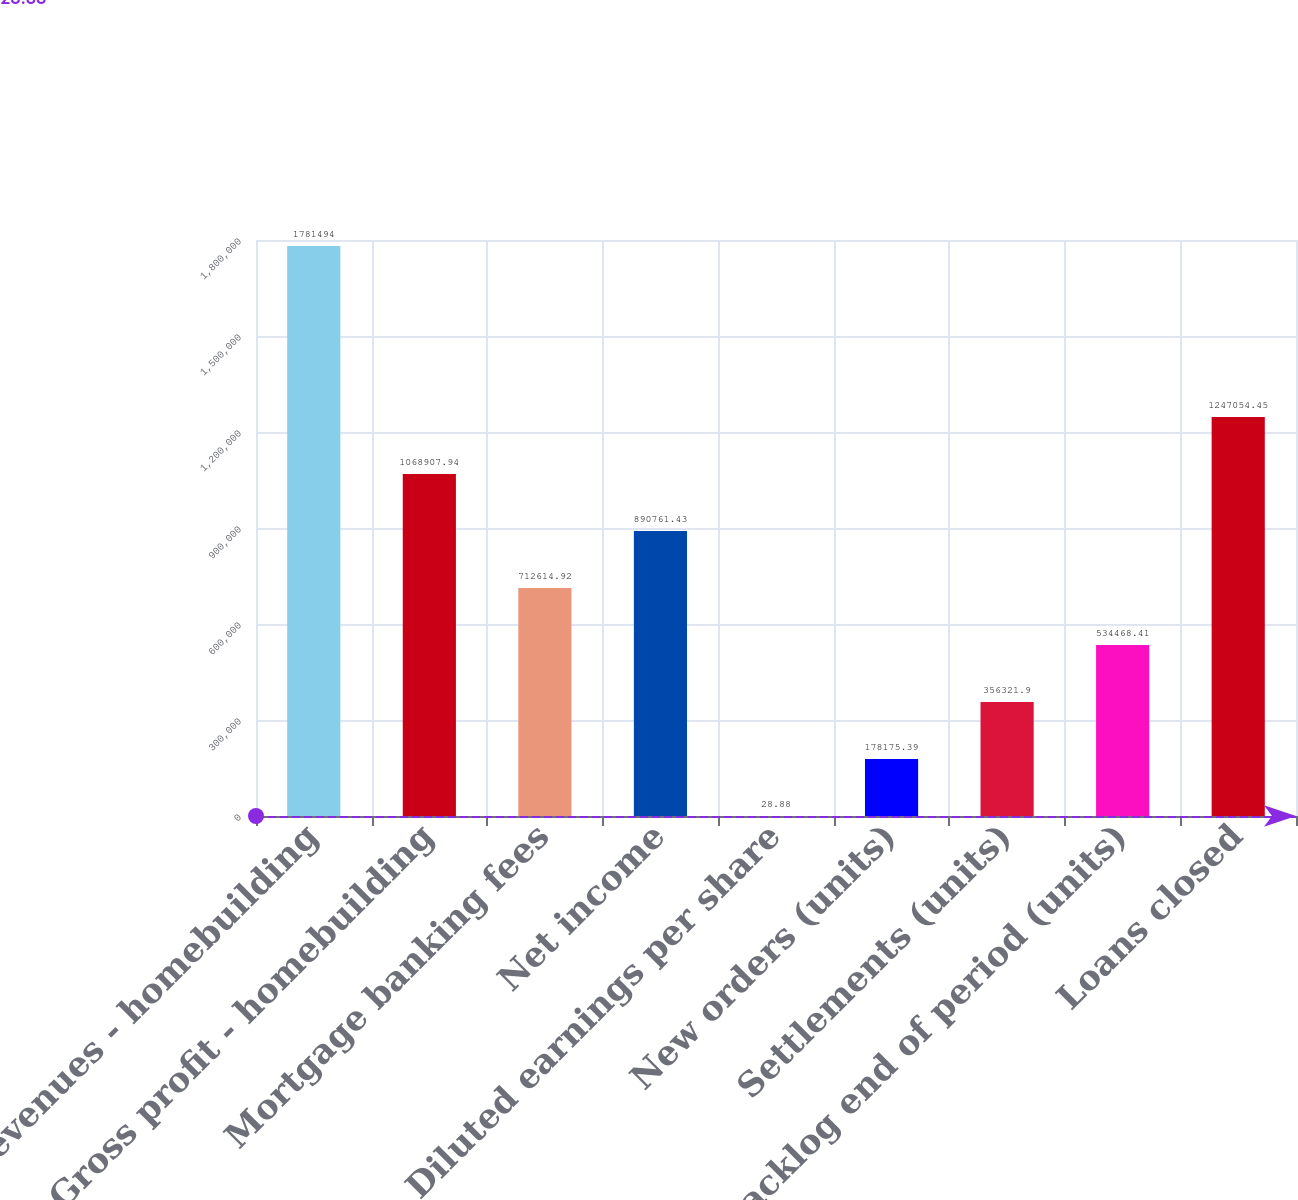<chart> <loc_0><loc_0><loc_500><loc_500><bar_chart><fcel>Revenues - homebuilding<fcel>Gross profit - homebuilding<fcel>Mortgage banking fees<fcel>Net income<fcel>Diluted earnings per share<fcel>New orders (units)<fcel>Settlements (units)<fcel>Backlog end of period (units)<fcel>Loans closed<nl><fcel>1.78149e+06<fcel>1.06891e+06<fcel>712615<fcel>890761<fcel>28.88<fcel>178175<fcel>356322<fcel>534468<fcel>1.24705e+06<nl></chart> 